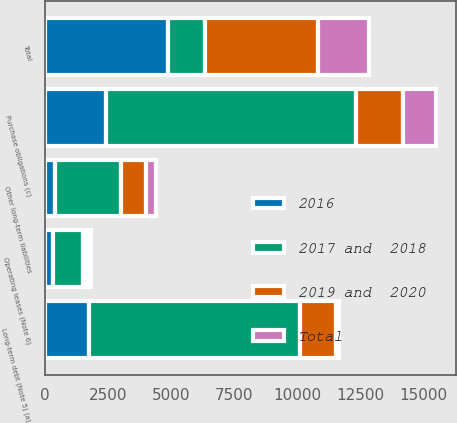<chart> <loc_0><loc_0><loc_500><loc_500><stacked_bar_chart><ecel><fcel>Long-term debt (Note 5) (a)<fcel>Other long-term liabilities<fcel>Operating leases (Note 6)<fcel>Purchase obligations (c)<fcel>Total<nl><fcel>2017 and  2018<fcel>8357<fcel>2604<fcel>1175<fcel>9906<fcel>1450<nl><fcel>2019 and  2020<fcel>1450<fcel>983<fcel>179<fcel>1890<fcel>4502<nl><fcel>2016<fcel>1750<fcel>415<fcel>317<fcel>2420<fcel>4902<nl><fcel>Total<fcel>116<fcel>393<fcel>171<fcel>1321<fcel>2001<nl></chart> 